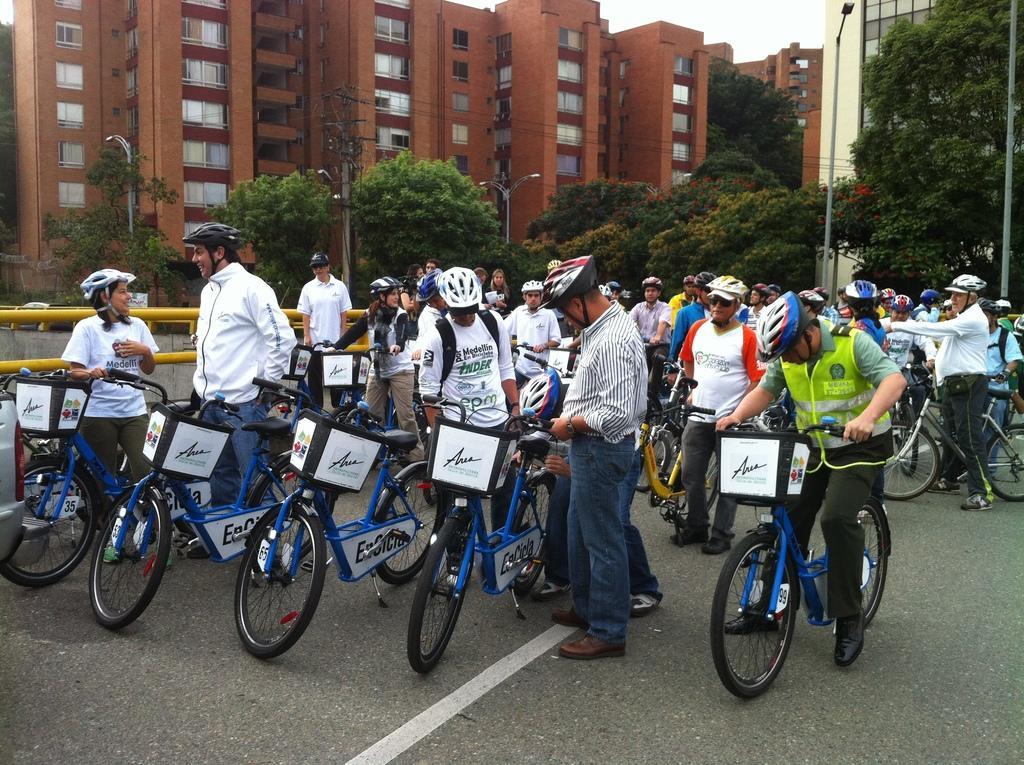Can you describe this image briefly? At the top we can see a sky. Here we can see huge buildings, trees, lights and a current pole. Here on the road we can see all the persons standing with bicycles. They all wore helmets. 